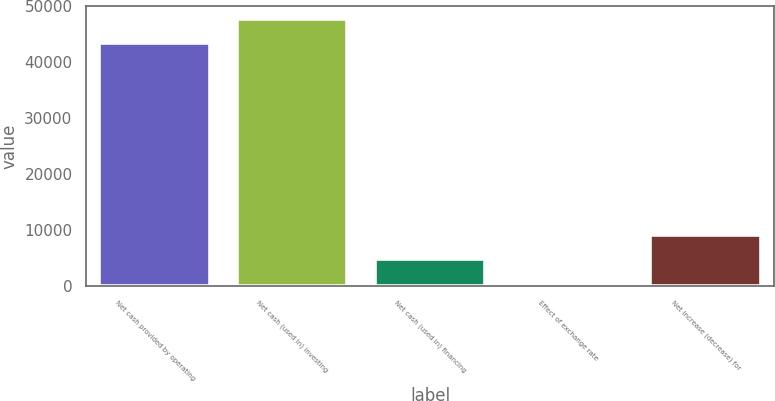<chart> <loc_0><loc_0><loc_500><loc_500><bar_chart><fcel>Net cash provided by operating<fcel>Net cash (used in) investing<fcel>Net cash (used in) financing<fcel>Effect of exchange rate<fcel>Net increase (decrease) for<nl><fcel>43327<fcel>47693.7<fcel>4864.7<fcel>498<fcel>9231.4<nl></chart> 